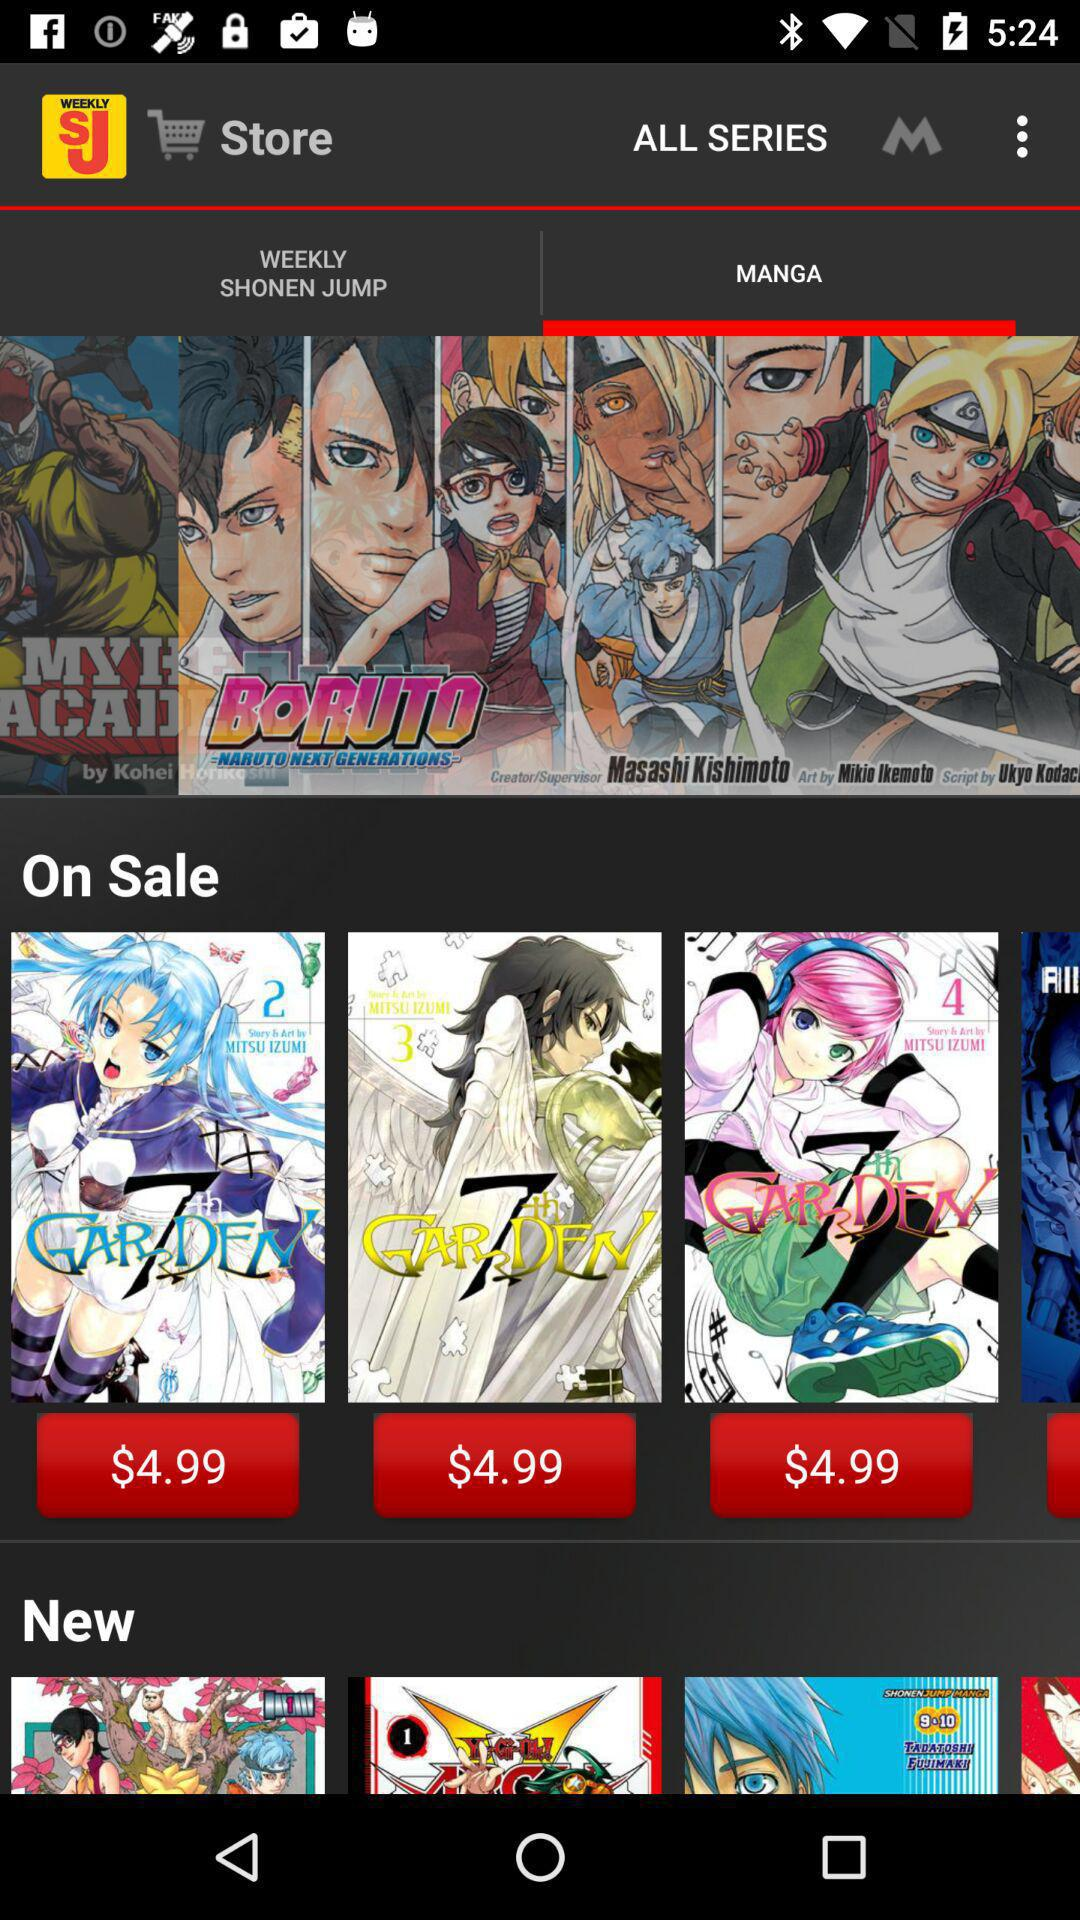How much does a weekly subscription cost? The weekly subscription cost is $0.99. 